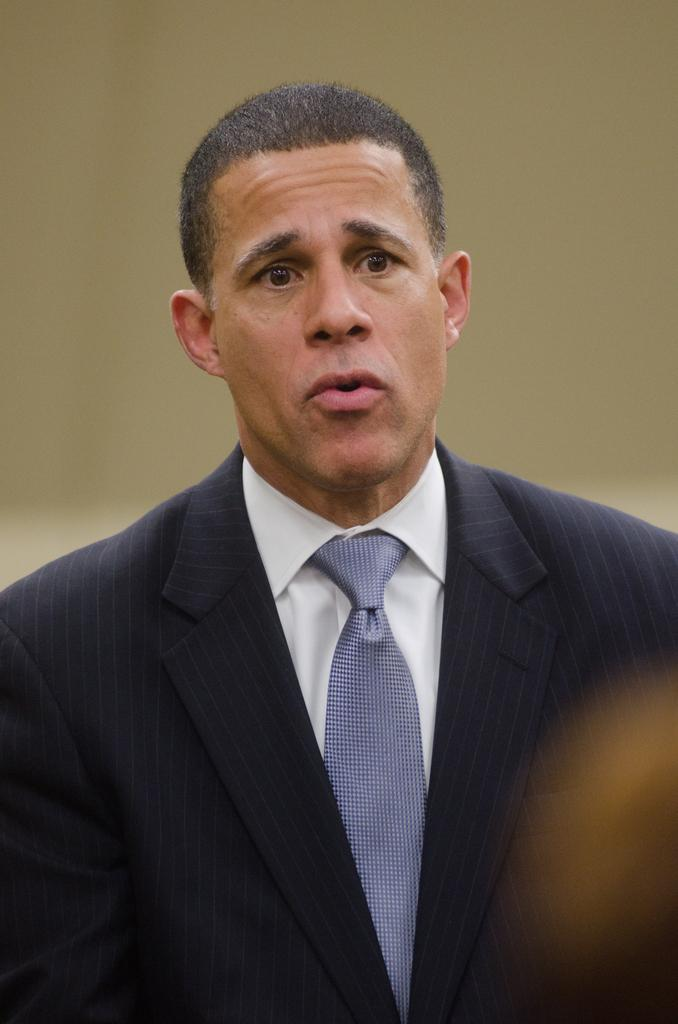Who is present in the image? There is a man in the image. What is the man's facial expression? The man is giving a shocked expression. What color is the man's shirt? The man is wearing a white shirt. What color is the man's tie? The man is wearing a blue tie. What color is the man's blazer? The man is wearing a blue blazer. How is the background of the man depicted in the image? The background of the man is blurred. What country is the man standing in during the match in the image? There is no match or country mentioned in the image, and the man is not standing; he is giving a shocked expression. 